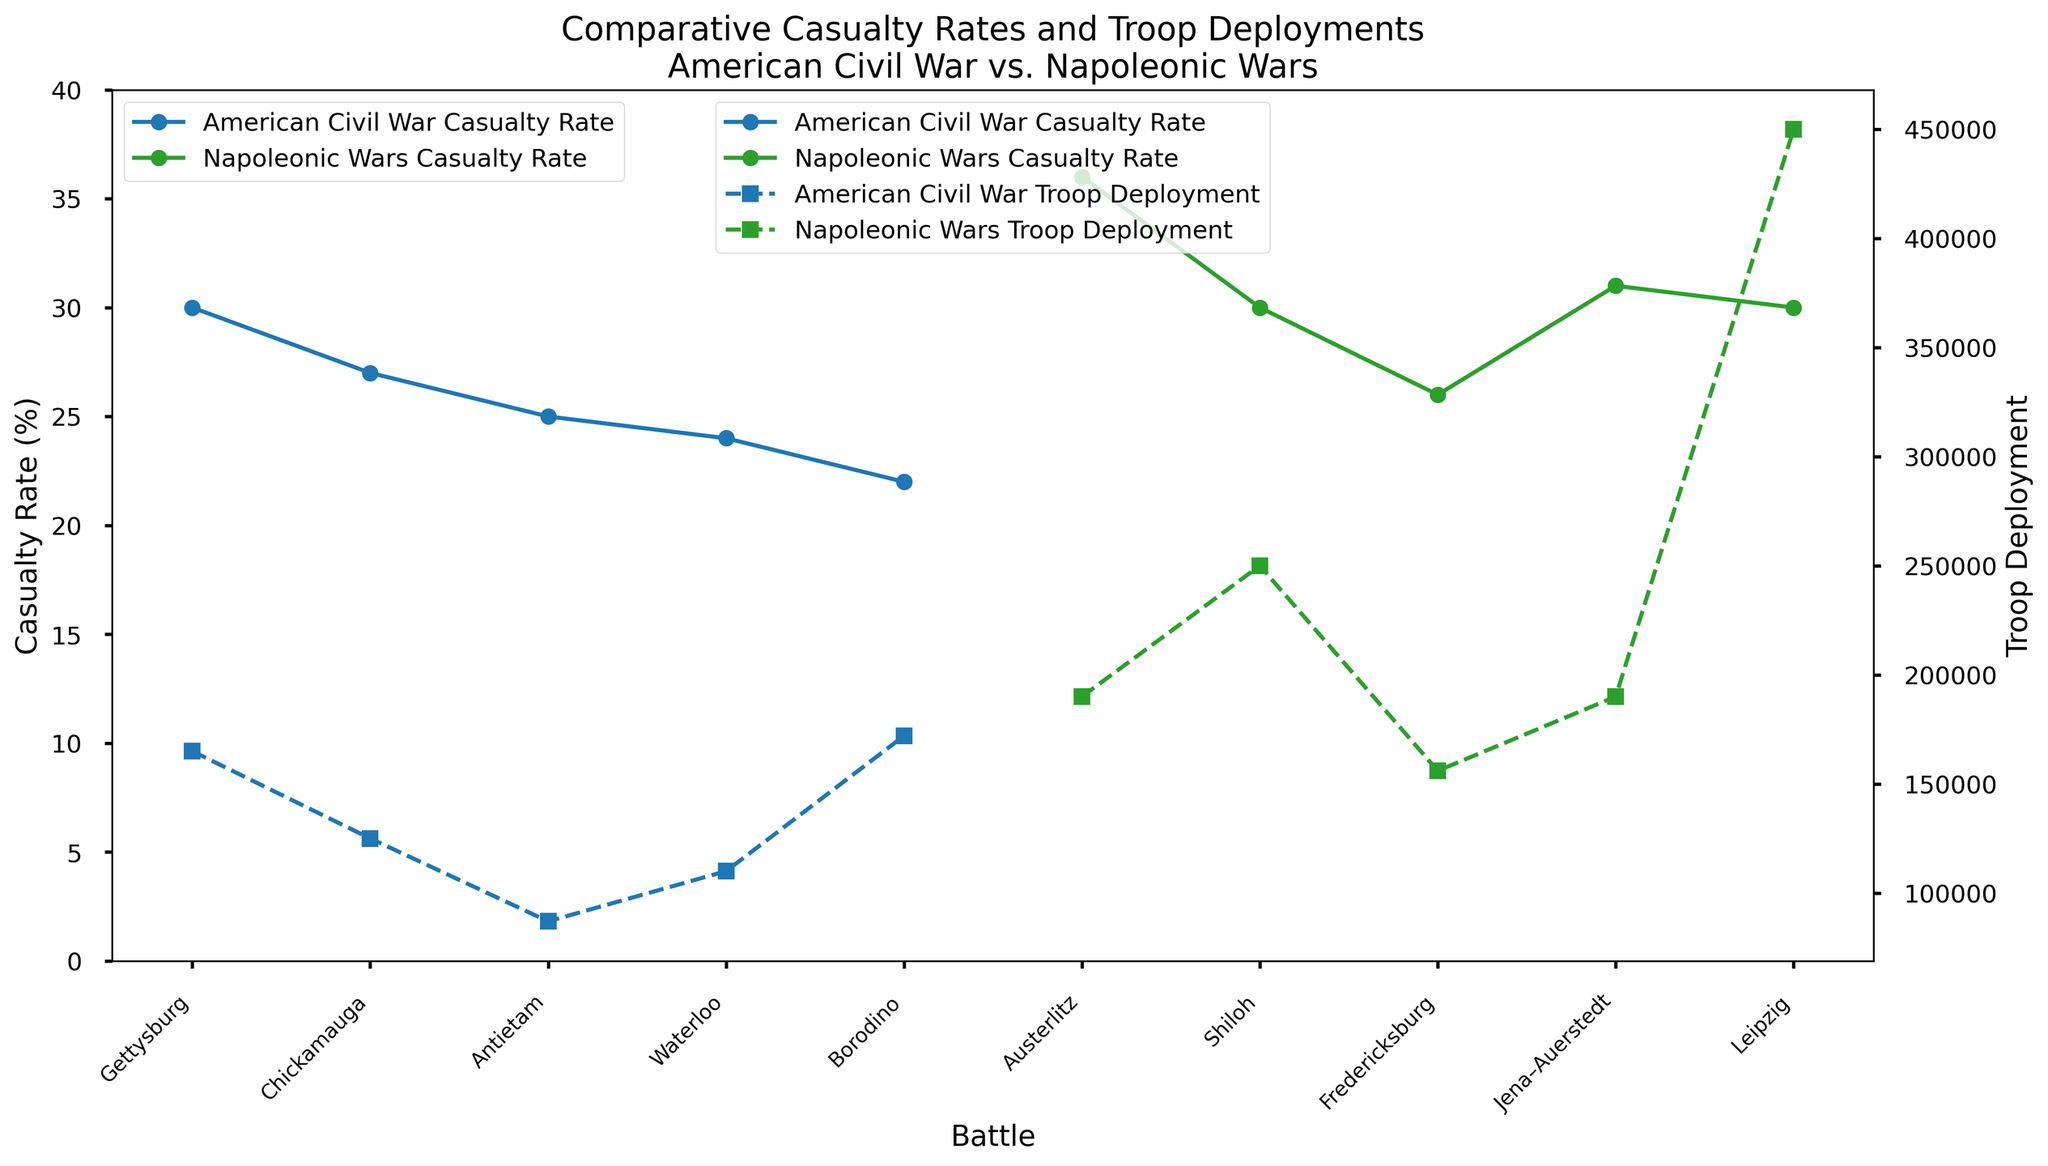Which battle has the highest casualty rate? By looking at the y-axis representing the casualty rate (%), the highest point is achieved by the Waterloo battle in the Napoleonic Wars.
Answer: Waterloo Which battle in the American Civil War had the highest causalities rate? By scrutinizing the blue lines representing the American Civil War's casualty rates, the peak is at the battle of Gettysburg.
Answer: Gettysburg Compare the troop deployments between the Battle of Antietam and the Battle of Shiloh. Which one had more troops? To draw the comparison, observe the secondary axis (right) and check the values for Antietam and Shiloh. Antietam had 87,000 troops, whereas Shiloh had 110,000 troops.
Answer: Shiloh Is there a battle with equal casualty rates between the Napoleonic Wars and the American Civil War? By looking at the graphs, we note that both the Battle of Gettysburg (American Civil War) and the Battle of Borodino (Napoleonic Wars) show a casualty rate of 30%.
Answer: Yes What is the average troop deployment for battles in the Napoleonic Wars? Calculate the average deployment by summing the troop deployments for Waterloo (190,000), Borodino (250,000), Austerlitz (156,000), Jena-Auerstedt (190,000), and Leipzig (450,000), then divide by 5. [(190,000 + 250,000 + 156,000 + 190,000 + 450,000)/5 = 1,236,000/5]
Answer: 247,200 Which war saw the highest casualty rate more frequently; is it the Napoleonic Wars or the American Civil War? By noting the peaks of the green and blue lines representing the casualty rates, it is observed that the Napoleonic Wars (green) more frequently reach higher peaks, especially with battles like Waterloo (36%) and Jena–Auerstedt (31%).
Answer: Napoleonic Wars What is the difference in troop deployment between the Battle of Leipzig and the Battle of Chickamauga? Subtract the troop deployment of Chickamauga (125,000) from Leipzig (450,000). [450,000 - 125,000 = 325,000]
Answer: 325,000 Which battle from the American Civil War has the least number of troops deployed, and what is that number? By locating the lowest point among the blue markers representing troop deployment for American Civil War battles, it is found that the Battle of Antietam had the least number of troops with 87,000.
Answer: Antietam – 87,000 Are there any battles where the casualty rate is below 25%? If so, name them. Look at the casualty rate (y-axis) for points below 25%. In the American Civil War: Fredericksburg (22%) and Shiloh (24%). In the Napoleonic Wars: None below 25%.
Answer: Fredericksburg, Shiloh How does the troop deployment in the Battle of Borodino compare to the Battle of Gettysburg? Compare the values on the secondary axis (right) for both battles. Borodino has 250,000 troops, whereas Gettysburg has 165,000 troops. Borodino had more deployments.
Answer: Borodino had more troops 